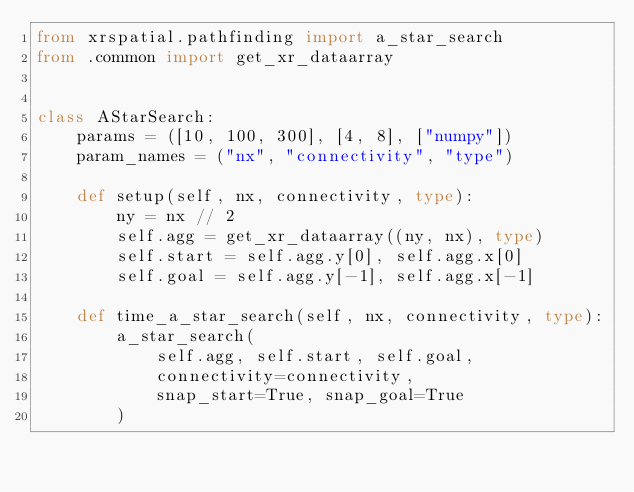<code> <loc_0><loc_0><loc_500><loc_500><_Python_>from xrspatial.pathfinding import a_star_search
from .common import get_xr_dataarray


class AStarSearch:
    params = ([10, 100, 300], [4, 8], ["numpy"])
    param_names = ("nx", "connectivity", "type")

    def setup(self, nx, connectivity, type):
        ny = nx // 2
        self.agg = get_xr_dataarray((ny, nx), type)
        self.start = self.agg.y[0], self.agg.x[0]
        self.goal = self.agg.y[-1], self.agg.x[-1]

    def time_a_star_search(self, nx, connectivity, type):
        a_star_search(
            self.agg, self.start, self.goal,
            connectivity=connectivity,
            snap_start=True, snap_goal=True
        )
</code> 